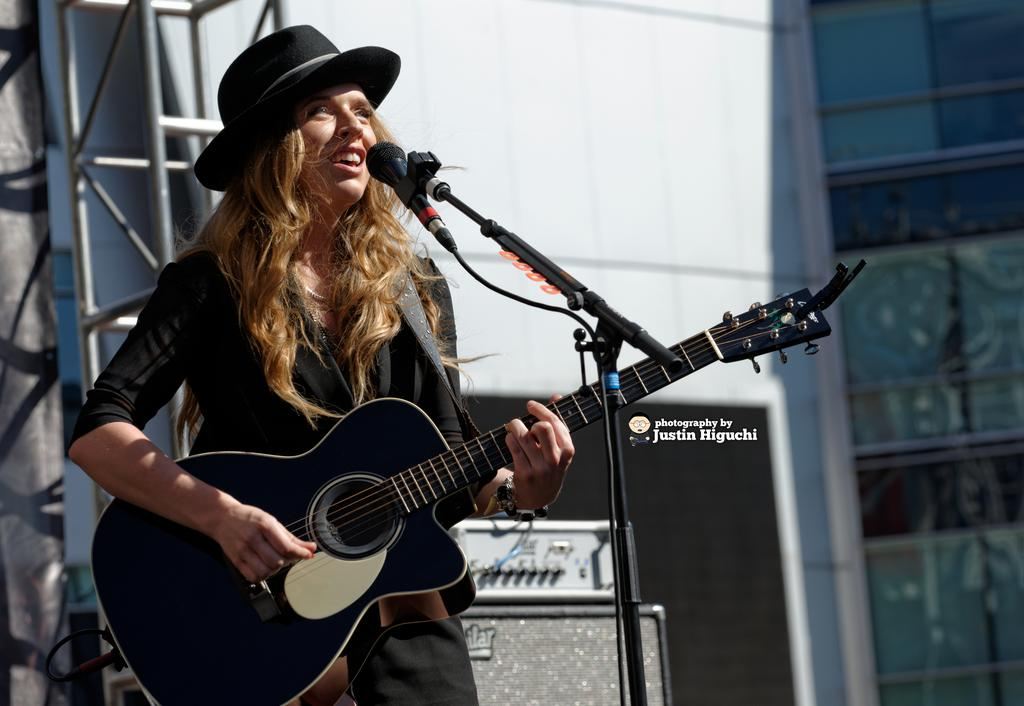What is the person in the image doing? The person is standing and playing a guitar while singing. What is the person wearing on their head? The person is wearing a hat. What is used for amplifying the person's voice in the image? There is a microphone with a stand. What can be seen in the background of the image? There is a wall, a glass window, an electrical object, and a rod in the background. What type of frame is the person using to hold their breakfast in the image? There is no frame or breakfast present in the image; it features a person playing a guitar and singing. 